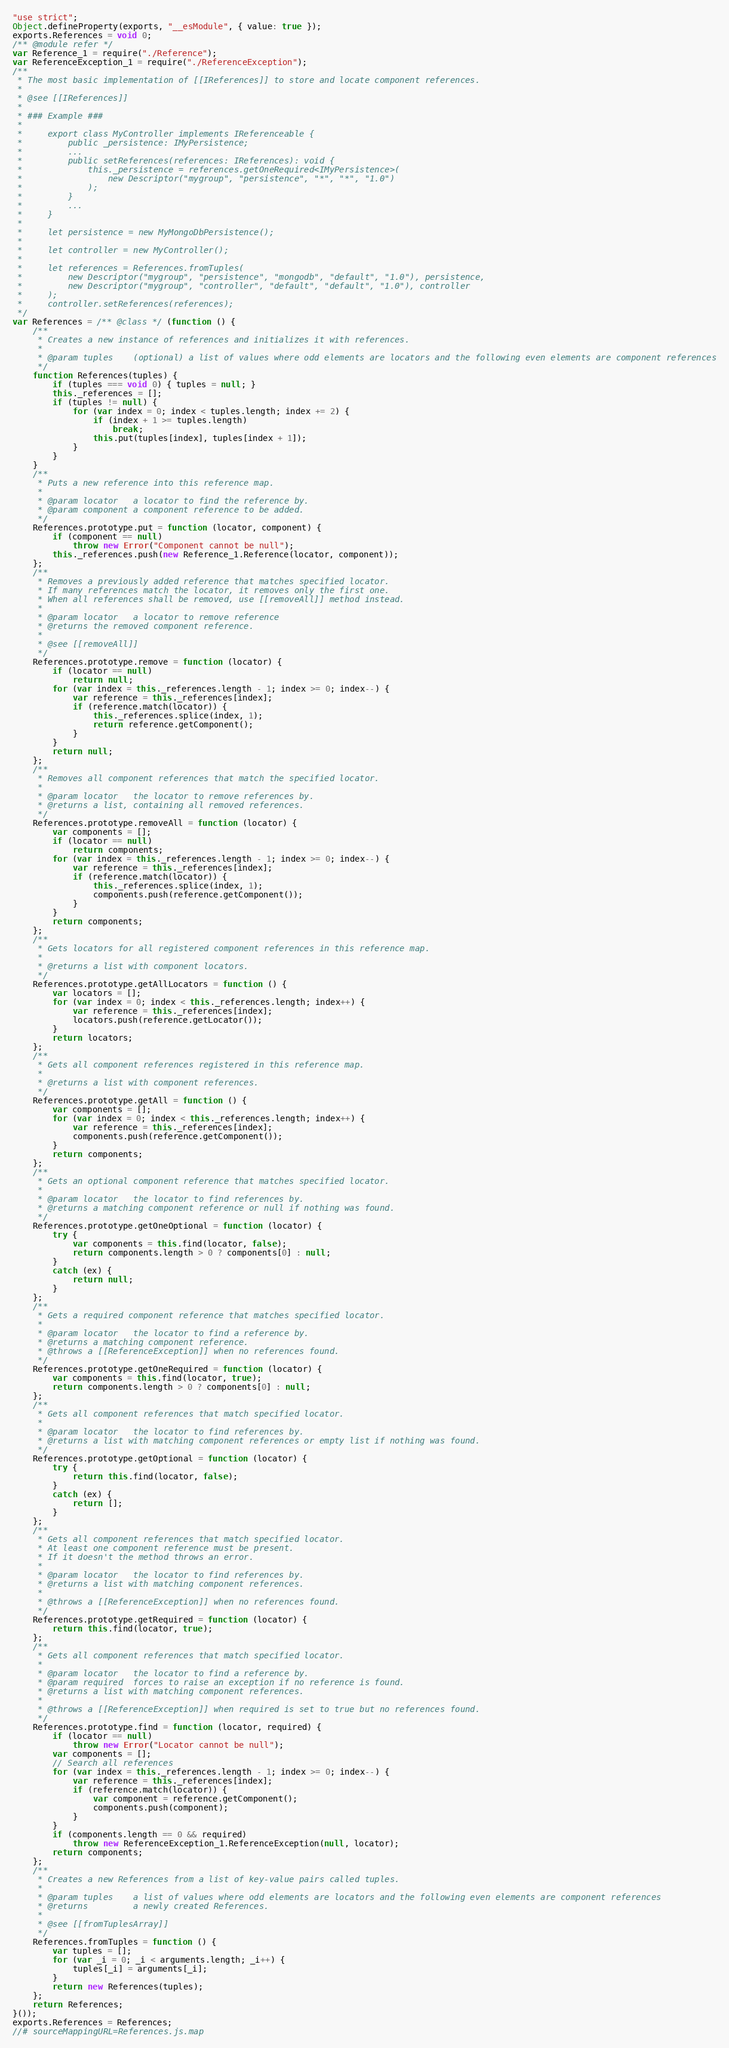<code> <loc_0><loc_0><loc_500><loc_500><_JavaScript_>"use strict";
Object.defineProperty(exports, "__esModule", { value: true });
exports.References = void 0;
/** @module refer */
var Reference_1 = require("./Reference");
var ReferenceException_1 = require("./ReferenceException");
/**
 * The most basic implementation of [[IReferences]] to store and locate component references.
 *
 * @see [[IReferences]]
 *
 * ### Example ###
 *
 *     export class MyController implements IReferenceable {
 *         public _persistence: IMyPersistence;
 *         ...
 *         public setReferences(references: IReferences): void {
 *             this._persistence = references.getOneRequired<IMyPersistence>(
 *                 new Descriptor("mygroup", "persistence", "*", "*", "1.0")
 *             );
 *         }
 *         ...
 *     }
 *
 *     let persistence = new MyMongoDbPersistence();
 *
 *     let controller = new MyController();
 *
 *     let references = References.fromTuples(
 *         new Descriptor("mygroup", "persistence", "mongodb", "default", "1.0"), persistence,
 *         new Descriptor("mygroup", "controller", "default", "default", "1.0"), controller
 *     );
 *     controller.setReferences(references);
 */
var References = /** @class */ (function () {
    /**
     * Creates a new instance of references and initializes it with references.
     *
     * @param tuples    (optional) a list of values where odd elements are locators and the following even elements are component references
     */
    function References(tuples) {
        if (tuples === void 0) { tuples = null; }
        this._references = [];
        if (tuples != null) {
            for (var index = 0; index < tuples.length; index += 2) {
                if (index + 1 >= tuples.length)
                    break;
                this.put(tuples[index], tuples[index + 1]);
            }
        }
    }
    /**
     * Puts a new reference into this reference map.
     *
     * @param locator 	a locator to find the reference by.
     * @param component a component reference to be added.
     */
    References.prototype.put = function (locator, component) {
        if (component == null)
            throw new Error("Component cannot be null");
        this._references.push(new Reference_1.Reference(locator, component));
    };
    /**
     * Removes a previously added reference that matches specified locator.
     * If many references match the locator, it removes only the first one.
     * When all references shall be removed, use [[removeAll]] method instead.
     *
     * @param locator 	a locator to remove reference
     * @returns the removed component reference.
     *
     * @see [[removeAll]]
     */
    References.prototype.remove = function (locator) {
        if (locator == null)
            return null;
        for (var index = this._references.length - 1; index >= 0; index--) {
            var reference = this._references[index];
            if (reference.match(locator)) {
                this._references.splice(index, 1);
                return reference.getComponent();
            }
        }
        return null;
    };
    /**
     * Removes all component references that match the specified locator.
     *
     * @param locator 	the locator to remove references by.
     * @returns a list, containing all removed references.
     */
    References.prototype.removeAll = function (locator) {
        var components = [];
        if (locator == null)
            return components;
        for (var index = this._references.length - 1; index >= 0; index--) {
            var reference = this._references[index];
            if (reference.match(locator)) {
                this._references.splice(index, 1);
                components.push(reference.getComponent());
            }
        }
        return components;
    };
    /**
     * Gets locators for all registered component references in this reference map.
     *
     * @returns a list with component locators.
     */
    References.prototype.getAllLocators = function () {
        var locators = [];
        for (var index = 0; index < this._references.length; index++) {
            var reference = this._references[index];
            locators.push(reference.getLocator());
        }
        return locators;
    };
    /**
     * Gets all component references registered in this reference map.
     *
     * @returns a list with component references.
     */
    References.prototype.getAll = function () {
        var components = [];
        for (var index = 0; index < this._references.length; index++) {
            var reference = this._references[index];
            components.push(reference.getComponent());
        }
        return components;
    };
    /**
     * Gets an optional component reference that matches specified locator.
     *
     * @param locator 	the locator to find references by.
     * @returns a matching component reference or null if nothing was found.
     */
    References.prototype.getOneOptional = function (locator) {
        try {
            var components = this.find(locator, false);
            return components.length > 0 ? components[0] : null;
        }
        catch (ex) {
            return null;
        }
    };
    /**
     * Gets a required component reference that matches specified locator.
     *
     * @param locator 	the locator to find a reference by.
     * @returns a matching component reference.
     * @throws a [[ReferenceException]] when no references found.
     */
    References.prototype.getOneRequired = function (locator) {
        var components = this.find(locator, true);
        return components.length > 0 ? components[0] : null;
    };
    /**
     * Gets all component references that match specified locator.
     *
     * @param locator 	the locator to find references by.
     * @returns a list with matching component references or empty list if nothing was found.
     */
    References.prototype.getOptional = function (locator) {
        try {
            return this.find(locator, false);
        }
        catch (ex) {
            return [];
        }
    };
    /**
     * Gets all component references that match specified locator.
     * At least one component reference must be present.
     * If it doesn't the method throws an error.
     *
     * @param locator 	the locator to find references by.
     * @returns a list with matching component references.
     *
     * @throws a [[ReferenceException]] when no references found.
     */
    References.prototype.getRequired = function (locator) {
        return this.find(locator, true);
    };
    /**
     * Gets all component references that match specified locator.
     *
     * @param locator 	the locator to find a reference by.
     * @param required 	forces to raise an exception if no reference is found.
     * @returns a list with matching component references.
     *
     * @throws a [[ReferenceException]] when required is set to true but no references found.
     */
    References.prototype.find = function (locator, required) {
        if (locator == null)
            throw new Error("Locator cannot be null");
        var components = [];
        // Search all references
        for (var index = this._references.length - 1; index >= 0; index--) {
            var reference = this._references[index];
            if (reference.match(locator)) {
                var component = reference.getComponent();
                components.push(component);
            }
        }
        if (components.length == 0 && required)
            throw new ReferenceException_1.ReferenceException(null, locator);
        return components;
    };
    /**
     * Creates a new References from a list of key-value pairs called tuples.
     *
     * @param tuples    a list of values where odd elements are locators and the following even elements are component references
     * @returns         a newly created References.
     *
     * @see [[fromTuplesArray]]
     */
    References.fromTuples = function () {
        var tuples = [];
        for (var _i = 0; _i < arguments.length; _i++) {
            tuples[_i] = arguments[_i];
        }
        return new References(tuples);
    };
    return References;
}());
exports.References = References;
//# sourceMappingURL=References.js.map</code> 